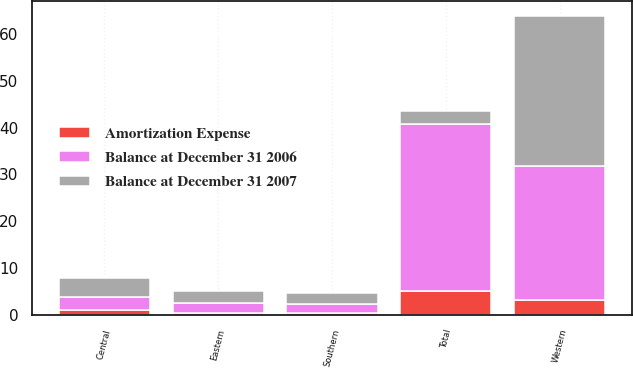Convert chart. <chart><loc_0><loc_0><loc_500><loc_500><stacked_bar_chart><ecel><fcel>Eastern<fcel>Central<fcel>Southern<fcel>Western<fcel>Total<nl><fcel>Balance at December 31 2006<fcel>2.1<fcel>2.9<fcel>2<fcel>28.6<fcel>35.6<nl><fcel>Amortization Expense<fcel>0.5<fcel>1<fcel>0.4<fcel>3.3<fcel>5.2<nl><fcel>Balance at December 31 2007<fcel>2.6<fcel>3.9<fcel>2.4<fcel>31.9<fcel>2.75<nl></chart> 